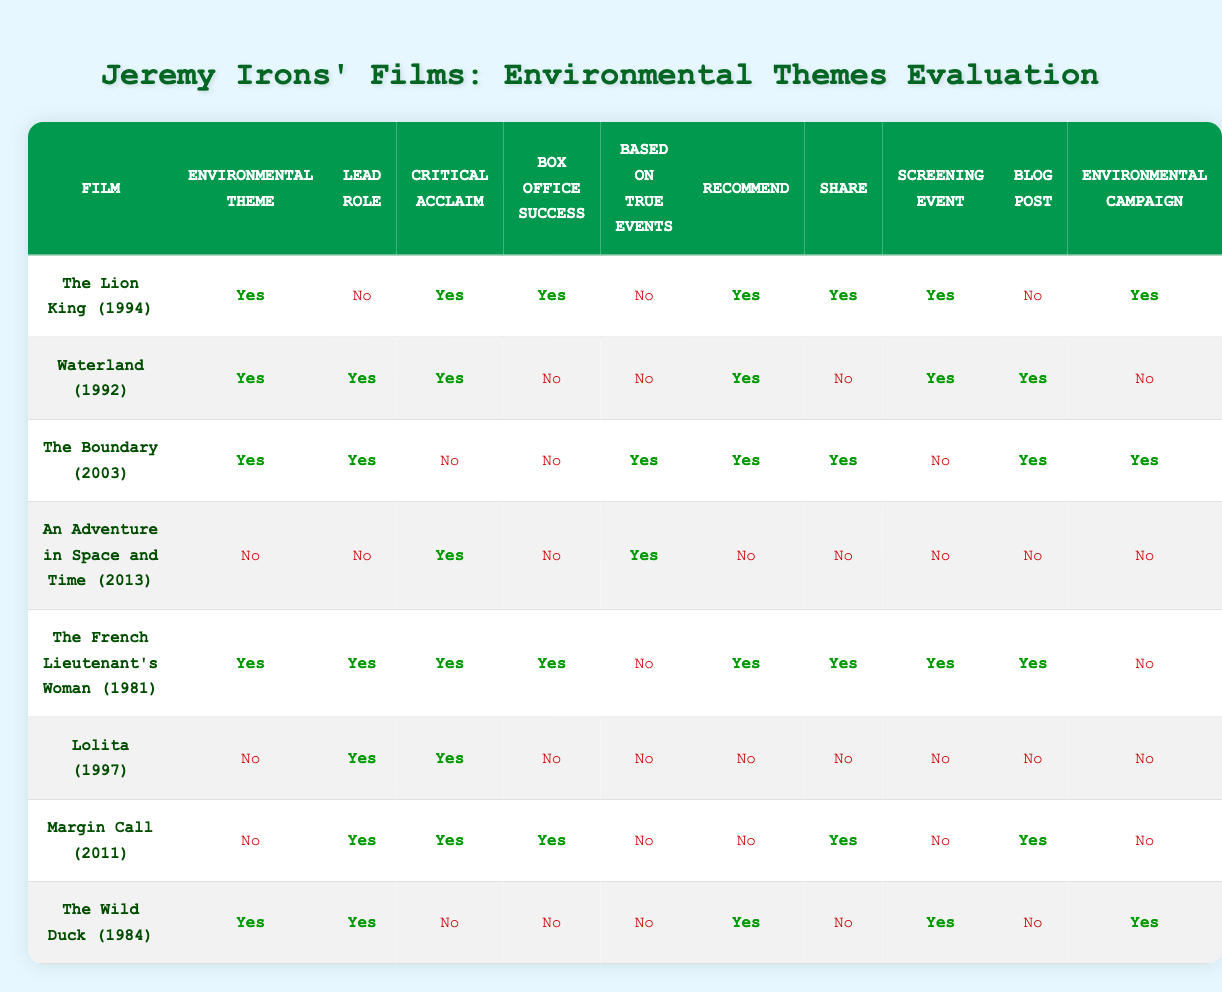What films with environmental themes were recommended for viewing? To find the films recommended for viewing, we need to look for rows where "Recommend" is marked as Yes. This includes "The Lion King (1994)", "Waterland (1992)", "The Boundary (2003)", "The French Lieutenant's Woman (1981)", and "The Wild Duck (1984)".
Answer: The Lion King (1994), Waterland (1992), The Boundary (2003), The French Lieutenant's Woman (1981), The Wild Duck (1984) Which film had a lead role and was based on true events while also being critically acclaimed? The search criteria require checking the film rows for "Lead role" as Yes, "Based on true events" as Yes, and "Critical acclaim" as Yes. The films "Waterland (1992)", "The Boundary (2003)", and "The French Lieutenant's Woman (1981)" meet these criteria.
Answer: Waterland (1992), The Boundary (2003), The French Lieutenant's Woman (1981) How many films that feature an environmental theme are also not box office successes? We must identify films where "Environmental theme" is Yes and "Box office success" is No. The relevant films found in the table are "The Boundary (2003)", "An Adventure in Space and Time (2013)", "The Wild Duck (1984)", totaling three films.
Answer: 3 Did any films use their story in an environmental campaign? We check the "Environmental campaign" column for films that are marked Yes. The films that qualify are "The Lion King (1994)", "The Boundary (2003)", "The Wild Duck (1984)", and "The French Lieutenant's Woman (1981)".
Answer: Yes Which film had a critical acclaim but did not have an environmental theme? The requirement is to find films marked Yes in "Critical acclaim" and No in "Environmental theme". The only film fitting this is "Lolita (1997)".
Answer: Lolita (1997) How many films had a lead role without an environmental theme and were critically acclaimed? We need to find films where "Lead role" is Yes, "Environmental theme" is No, and "Critical acclaim" is Yes. The film "Margin Call (2011)" meets these criteria.
Answer: 1 What is the total number of films that were both critically acclaimed and successful at the box office? We need to look for films where "Critical acclaim" is Yes and "Box office success" is Yes. The films fulfilling this are "The Lion King (1994)", "The French Lieutenant's Woman (1981)", and "Margin Call (2011)", resulting in a total of three films.
Answer: 3 Name the films that can be used in an environmental campaign and also had a lead role. To answer this, we must find films with "Lead role" as Yes and "Environmental campaign" as Yes. The films identified are "The Boundary (2003)", "The Wild Duck (1984)", and "The Lion King (1994)".
Answer: The Boundary (2003), The Wild Duck (1984), The Lion King (1994) How many films are based on true events without any environmental themes? We investigate films where "Based on true events" is Yes and "Environmental theme" is No. The film that fits this criterion is "An Adventure in Space and Time (2013)", making it one film in total.
Answer: 1 